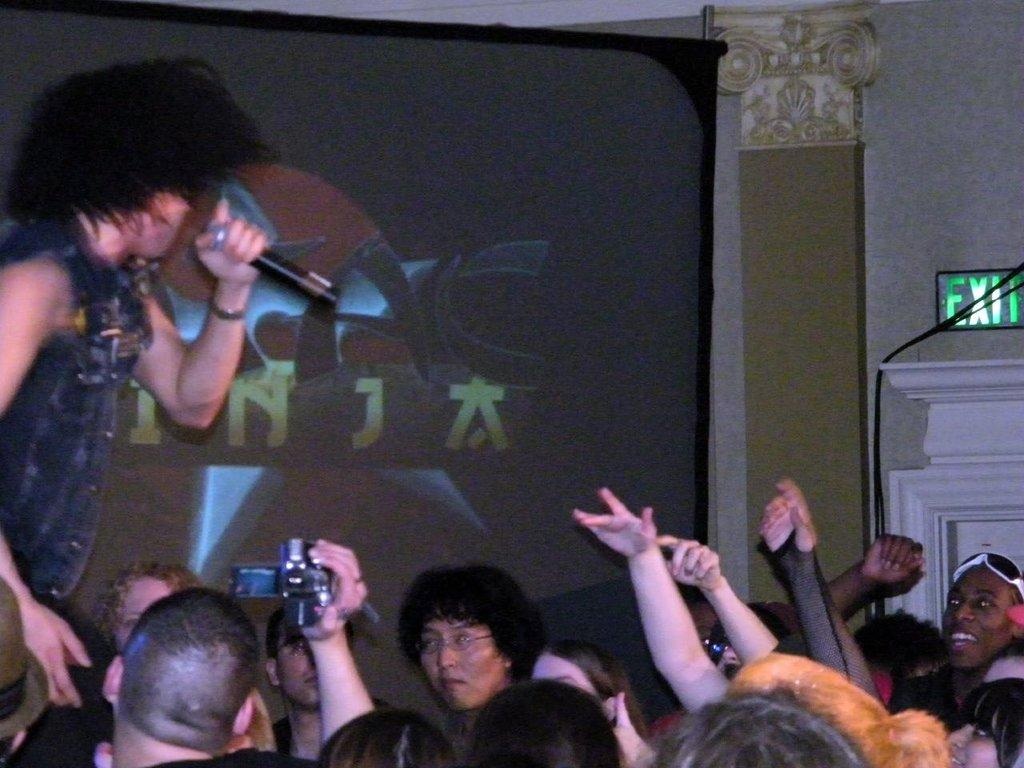How many people are present in the image? There are many people in the image. What device can be seen in the image that is commonly used for taking photos? There is a camera phone in the image. What object is present in the image that is used for amplifying sound? There is a microphone in the image. What type of display is visible in the image? There is a screen in the image. What can be found in the image that provides guidance or information? There is an instruction board in the image. Can you see any hills in the background of the image? There are no hills visible in the image. Is there a birthday celebration taking place in the image? There is no indication of a birthday celebration in the image. 